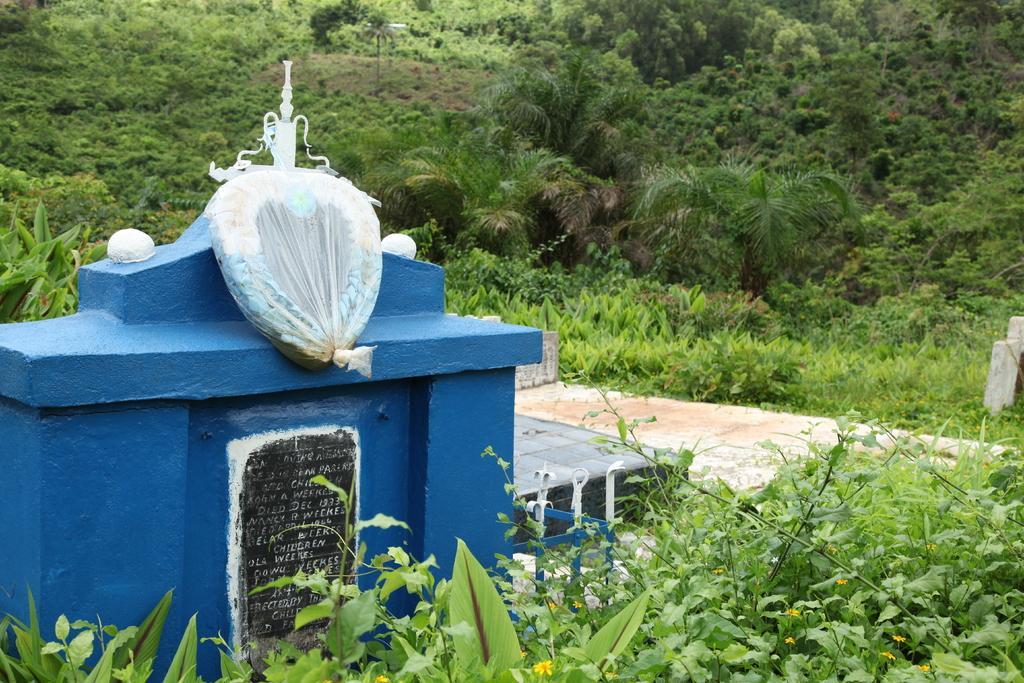In one or two sentences, can you explain what this image depicts? In this picture we can see trees on the background and this is a pole. In Front of the picture we can see plants. This is a flower. We can see a wall painted with blue paint colour. This is a marble stone and there is something written on it. This is a garland packed in a polythene cover. 